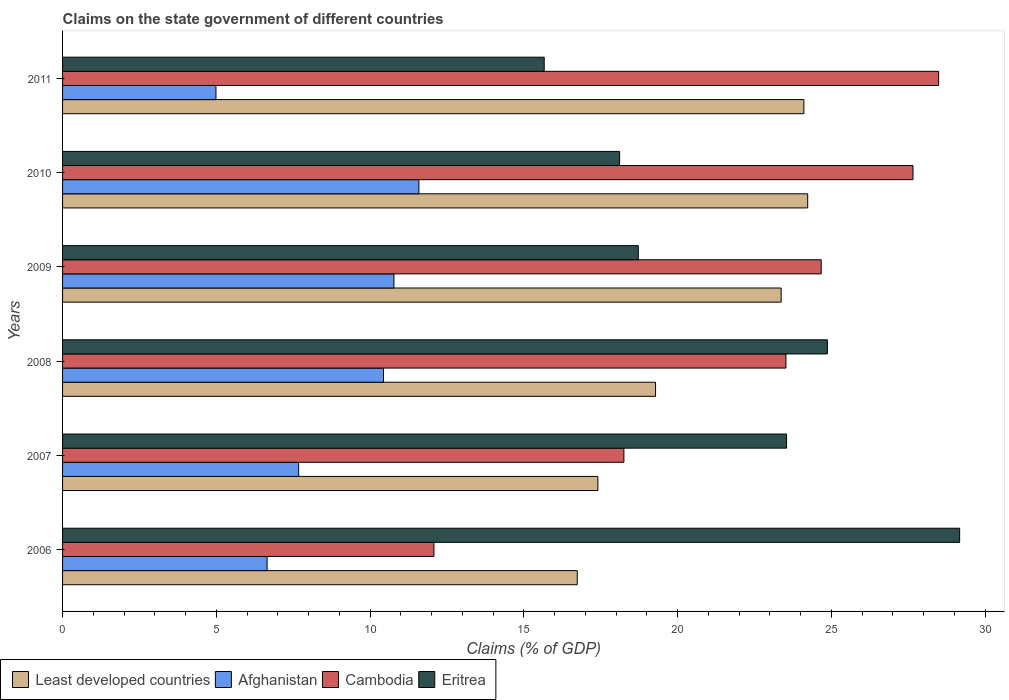How many groups of bars are there?
Provide a succinct answer. 6. Are the number of bars per tick equal to the number of legend labels?
Provide a short and direct response. Yes. What is the label of the 4th group of bars from the top?
Offer a terse response. 2008. What is the percentage of GDP claimed on the state government in Cambodia in 2010?
Offer a very short reply. 27.65. Across all years, what is the maximum percentage of GDP claimed on the state government in Eritrea?
Provide a succinct answer. 29.17. Across all years, what is the minimum percentage of GDP claimed on the state government in Least developed countries?
Keep it short and to the point. 16.74. In which year was the percentage of GDP claimed on the state government in Cambodia maximum?
Provide a succinct answer. 2011. What is the total percentage of GDP claimed on the state government in Eritrea in the graph?
Provide a succinct answer. 130.08. What is the difference between the percentage of GDP claimed on the state government in Cambodia in 2006 and that in 2011?
Make the answer very short. -16.41. What is the difference between the percentage of GDP claimed on the state government in Eritrea in 2008 and the percentage of GDP claimed on the state government in Cambodia in 2007?
Keep it short and to the point. 6.62. What is the average percentage of GDP claimed on the state government in Eritrea per year?
Offer a very short reply. 21.68. In the year 2006, what is the difference between the percentage of GDP claimed on the state government in Eritrea and percentage of GDP claimed on the state government in Least developed countries?
Your response must be concise. 12.43. In how many years, is the percentage of GDP claimed on the state government in Cambodia greater than 18 %?
Make the answer very short. 5. What is the ratio of the percentage of GDP claimed on the state government in Eritrea in 2007 to that in 2009?
Make the answer very short. 1.26. Is the percentage of GDP claimed on the state government in Afghanistan in 2007 less than that in 2008?
Make the answer very short. Yes. Is the difference between the percentage of GDP claimed on the state government in Eritrea in 2010 and 2011 greater than the difference between the percentage of GDP claimed on the state government in Least developed countries in 2010 and 2011?
Provide a short and direct response. Yes. What is the difference between the highest and the second highest percentage of GDP claimed on the state government in Cambodia?
Give a very brief answer. 0.83. What is the difference between the highest and the lowest percentage of GDP claimed on the state government in Least developed countries?
Your answer should be compact. 7.49. What does the 1st bar from the top in 2007 represents?
Your answer should be very brief. Eritrea. What does the 4th bar from the bottom in 2008 represents?
Offer a terse response. Eritrea. How many years are there in the graph?
Provide a succinct answer. 6. What is the difference between two consecutive major ticks on the X-axis?
Provide a short and direct response. 5. Does the graph contain any zero values?
Ensure brevity in your answer.  No. Where does the legend appear in the graph?
Keep it short and to the point. Bottom left. How many legend labels are there?
Provide a short and direct response. 4. How are the legend labels stacked?
Give a very brief answer. Horizontal. What is the title of the graph?
Give a very brief answer. Claims on the state government of different countries. Does "Syrian Arab Republic" appear as one of the legend labels in the graph?
Provide a succinct answer. No. What is the label or title of the X-axis?
Provide a short and direct response. Claims (% of GDP). What is the label or title of the Y-axis?
Your answer should be very brief. Years. What is the Claims (% of GDP) in Least developed countries in 2006?
Offer a very short reply. 16.74. What is the Claims (% of GDP) in Afghanistan in 2006?
Give a very brief answer. 6.65. What is the Claims (% of GDP) in Cambodia in 2006?
Your response must be concise. 12.08. What is the Claims (% of GDP) of Eritrea in 2006?
Keep it short and to the point. 29.17. What is the Claims (% of GDP) in Least developed countries in 2007?
Provide a succinct answer. 17.41. What is the Claims (% of GDP) in Afghanistan in 2007?
Ensure brevity in your answer.  7.68. What is the Claims (% of GDP) in Cambodia in 2007?
Ensure brevity in your answer.  18.25. What is the Claims (% of GDP) in Eritrea in 2007?
Provide a succinct answer. 23.54. What is the Claims (% of GDP) of Least developed countries in 2008?
Offer a terse response. 19.28. What is the Claims (% of GDP) of Afghanistan in 2008?
Offer a terse response. 10.44. What is the Claims (% of GDP) in Cambodia in 2008?
Ensure brevity in your answer.  23.52. What is the Claims (% of GDP) of Eritrea in 2008?
Your response must be concise. 24.87. What is the Claims (% of GDP) in Least developed countries in 2009?
Make the answer very short. 23.37. What is the Claims (% of GDP) in Afghanistan in 2009?
Your answer should be very brief. 10.78. What is the Claims (% of GDP) in Cambodia in 2009?
Provide a short and direct response. 24.67. What is the Claims (% of GDP) in Eritrea in 2009?
Offer a terse response. 18.72. What is the Claims (% of GDP) of Least developed countries in 2010?
Make the answer very short. 24.23. What is the Claims (% of GDP) in Afghanistan in 2010?
Offer a terse response. 11.59. What is the Claims (% of GDP) in Cambodia in 2010?
Your answer should be compact. 27.65. What is the Claims (% of GDP) in Eritrea in 2010?
Offer a very short reply. 18.11. What is the Claims (% of GDP) of Least developed countries in 2011?
Your response must be concise. 24.11. What is the Claims (% of GDP) of Afghanistan in 2011?
Give a very brief answer. 4.99. What is the Claims (% of GDP) of Cambodia in 2011?
Offer a very short reply. 28.49. What is the Claims (% of GDP) of Eritrea in 2011?
Make the answer very short. 15.66. Across all years, what is the maximum Claims (% of GDP) of Least developed countries?
Keep it short and to the point. 24.23. Across all years, what is the maximum Claims (% of GDP) in Afghanistan?
Your answer should be very brief. 11.59. Across all years, what is the maximum Claims (% of GDP) of Cambodia?
Ensure brevity in your answer.  28.49. Across all years, what is the maximum Claims (% of GDP) in Eritrea?
Your response must be concise. 29.17. Across all years, what is the minimum Claims (% of GDP) of Least developed countries?
Give a very brief answer. 16.74. Across all years, what is the minimum Claims (% of GDP) of Afghanistan?
Offer a very short reply. 4.99. Across all years, what is the minimum Claims (% of GDP) of Cambodia?
Your response must be concise. 12.08. Across all years, what is the minimum Claims (% of GDP) in Eritrea?
Provide a short and direct response. 15.66. What is the total Claims (% of GDP) in Least developed countries in the graph?
Provide a short and direct response. 125.12. What is the total Claims (% of GDP) in Afghanistan in the graph?
Keep it short and to the point. 52.11. What is the total Claims (% of GDP) in Cambodia in the graph?
Provide a short and direct response. 134.66. What is the total Claims (% of GDP) of Eritrea in the graph?
Your response must be concise. 130.08. What is the difference between the Claims (% of GDP) in Least developed countries in 2006 and that in 2007?
Offer a very short reply. -0.67. What is the difference between the Claims (% of GDP) of Afghanistan in 2006 and that in 2007?
Your answer should be very brief. -1.03. What is the difference between the Claims (% of GDP) of Cambodia in 2006 and that in 2007?
Your answer should be very brief. -6.18. What is the difference between the Claims (% of GDP) of Eritrea in 2006 and that in 2007?
Offer a very short reply. 5.63. What is the difference between the Claims (% of GDP) of Least developed countries in 2006 and that in 2008?
Keep it short and to the point. -2.55. What is the difference between the Claims (% of GDP) of Afghanistan in 2006 and that in 2008?
Offer a very short reply. -3.79. What is the difference between the Claims (% of GDP) of Cambodia in 2006 and that in 2008?
Keep it short and to the point. -11.45. What is the difference between the Claims (% of GDP) of Eritrea in 2006 and that in 2008?
Ensure brevity in your answer.  4.3. What is the difference between the Claims (% of GDP) of Least developed countries in 2006 and that in 2009?
Provide a succinct answer. -6.63. What is the difference between the Claims (% of GDP) of Afghanistan in 2006 and that in 2009?
Provide a succinct answer. -4.12. What is the difference between the Claims (% of GDP) in Cambodia in 2006 and that in 2009?
Offer a terse response. -12.59. What is the difference between the Claims (% of GDP) in Eritrea in 2006 and that in 2009?
Offer a terse response. 10.45. What is the difference between the Claims (% of GDP) of Least developed countries in 2006 and that in 2010?
Make the answer very short. -7.49. What is the difference between the Claims (% of GDP) in Afghanistan in 2006 and that in 2010?
Give a very brief answer. -4.94. What is the difference between the Claims (% of GDP) of Cambodia in 2006 and that in 2010?
Your answer should be very brief. -15.58. What is the difference between the Claims (% of GDP) in Eritrea in 2006 and that in 2010?
Give a very brief answer. 11.06. What is the difference between the Claims (% of GDP) of Least developed countries in 2006 and that in 2011?
Provide a succinct answer. -7.37. What is the difference between the Claims (% of GDP) of Afghanistan in 2006 and that in 2011?
Make the answer very short. 1.66. What is the difference between the Claims (% of GDP) in Cambodia in 2006 and that in 2011?
Give a very brief answer. -16.41. What is the difference between the Claims (% of GDP) in Eritrea in 2006 and that in 2011?
Give a very brief answer. 13.51. What is the difference between the Claims (% of GDP) of Least developed countries in 2007 and that in 2008?
Provide a succinct answer. -1.88. What is the difference between the Claims (% of GDP) of Afghanistan in 2007 and that in 2008?
Keep it short and to the point. -2.76. What is the difference between the Claims (% of GDP) of Cambodia in 2007 and that in 2008?
Offer a terse response. -5.27. What is the difference between the Claims (% of GDP) in Eritrea in 2007 and that in 2008?
Your answer should be very brief. -1.33. What is the difference between the Claims (% of GDP) in Least developed countries in 2007 and that in 2009?
Give a very brief answer. -5.96. What is the difference between the Claims (% of GDP) in Afghanistan in 2007 and that in 2009?
Give a very brief answer. -3.1. What is the difference between the Claims (% of GDP) in Cambodia in 2007 and that in 2009?
Your response must be concise. -6.42. What is the difference between the Claims (% of GDP) in Eritrea in 2007 and that in 2009?
Your answer should be compact. 4.82. What is the difference between the Claims (% of GDP) of Least developed countries in 2007 and that in 2010?
Ensure brevity in your answer.  -6.82. What is the difference between the Claims (% of GDP) in Afghanistan in 2007 and that in 2010?
Provide a short and direct response. -3.91. What is the difference between the Claims (% of GDP) in Cambodia in 2007 and that in 2010?
Your answer should be very brief. -9.4. What is the difference between the Claims (% of GDP) in Eritrea in 2007 and that in 2010?
Provide a succinct answer. 5.43. What is the difference between the Claims (% of GDP) in Least developed countries in 2007 and that in 2011?
Offer a very short reply. -6.7. What is the difference between the Claims (% of GDP) in Afghanistan in 2007 and that in 2011?
Ensure brevity in your answer.  2.69. What is the difference between the Claims (% of GDP) of Cambodia in 2007 and that in 2011?
Ensure brevity in your answer.  -10.23. What is the difference between the Claims (% of GDP) of Eritrea in 2007 and that in 2011?
Your response must be concise. 7.88. What is the difference between the Claims (% of GDP) of Least developed countries in 2008 and that in 2009?
Provide a short and direct response. -4.08. What is the difference between the Claims (% of GDP) in Afghanistan in 2008 and that in 2009?
Offer a very short reply. -0.34. What is the difference between the Claims (% of GDP) in Cambodia in 2008 and that in 2009?
Your answer should be compact. -1.15. What is the difference between the Claims (% of GDP) of Eritrea in 2008 and that in 2009?
Offer a very short reply. 6.15. What is the difference between the Claims (% of GDP) of Least developed countries in 2008 and that in 2010?
Provide a succinct answer. -4.95. What is the difference between the Claims (% of GDP) of Afghanistan in 2008 and that in 2010?
Give a very brief answer. -1.15. What is the difference between the Claims (% of GDP) of Cambodia in 2008 and that in 2010?
Ensure brevity in your answer.  -4.13. What is the difference between the Claims (% of GDP) in Eritrea in 2008 and that in 2010?
Your answer should be very brief. 6.76. What is the difference between the Claims (% of GDP) of Least developed countries in 2008 and that in 2011?
Your answer should be very brief. -4.82. What is the difference between the Claims (% of GDP) in Afghanistan in 2008 and that in 2011?
Ensure brevity in your answer.  5.45. What is the difference between the Claims (% of GDP) in Cambodia in 2008 and that in 2011?
Make the answer very short. -4.97. What is the difference between the Claims (% of GDP) of Eritrea in 2008 and that in 2011?
Make the answer very short. 9.21. What is the difference between the Claims (% of GDP) of Least developed countries in 2009 and that in 2010?
Your response must be concise. -0.86. What is the difference between the Claims (% of GDP) in Afghanistan in 2009 and that in 2010?
Offer a terse response. -0.81. What is the difference between the Claims (% of GDP) in Cambodia in 2009 and that in 2010?
Provide a succinct answer. -2.98. What is the difference between the Claims (% of GDP) of Eritrea in 2009 and that in 2010?
Provide a short and direct response. 0.61. What is the difference between the Claims (% of GDP) in Least developed countries in 2009 and that in 2011?
Provide a short and direct response. -0.74. What is the difference between the Claims (% of GDP) of Afghanistan in 2009 and that in 2011?
Make the answer very short. 5.79. What is the difference between the Claims (% of GDP) of Cambodia in 2009 and that in 2011?
Ensure brevity in your answer.  -3.82. What is the difference between the Claims (% of GDP) in Eritrea in 2009 and that in 2011?
Your response must be concise. 3.06. What is the difference between the Claims (% of GDP) in Least developed countries in 2010 and that in 2011?
Keep it short and to the point. 0.12. What is the difference between the Claims (% of GDP) of Afghanistan in 2010 and that in 2011?
Provide a short and direct response. 6.6. What is the difference between the Claims (% of GDP) of Cambodia in 2010 and that in 2011?
Give a very brief answer. -0.83. What is the difference between the Claims (% of GDP) in Eritrea in 2010 and that in 2011?
Keep it short and to the point. 2.45. What is the difference between the Claims (% of GDP) in Least developed countries in 2006 and the Claims (% of GDP) in Afghanistan in 2007?
Keep it short and to the point. 9.06. What is the difference between the Claims (% of GDP) in Least developed countries in 2006 and the Claims (% of GDP) in Cambodia in 2007?
Your response must be concise. -1.52. What is the difference between the Claims (% of GDP) in Least developed countries in 2006 and the Claims (% of GDP) in Eritrea in 2007?
Keep it short and to the point. -6.81. What is the difference between the Claims (% of GDP) of Afghanistan in 2006 and the Claims (% of GDP) of Cambodia in 2007?
Your answer should be very brief. -11.6. What is the difference between the Claims (% of GDP) of Afghanistan in 2006 and the Claims (% of GDP) of Eritrea in 2007?
Make the answer very short. -16.89. What is the difference between the Claims (% of GDP) in Cambodia in 2006 and the Claims (% of GDP) in Eritrea in 2007?
Offer a terse response. -11.47. What is the difference between the Claims (% of GDP) of Least developed countries in 2006 and the Claims (% of GDP) of Afghanistan in 2008?
Provide a short and direct response. 6.3. What is the difference between the Claims (% of GDP) in Least developed countries in 2006 and the Claims (% of GDP) in Cambodia in 2008?
Ensure brevity in your answer.  -6.79. What is the difference between the Claims (% of GDP) of Least developed countries in 2006 and the Claims (% of GDP) of Eritrea in 2008?
Ensure brevity in your answer.  -8.13. What is the difference between the Claims (% of GDP) of Afghanistan in 2006 and the Claims (% of GDP) of Cambodia in 2008?
Ensure brevity in your answer.  -16.87. What is the difference between the Claims (% of GDP) in Afghanistan in 2006 and the Claims (% of GDP) in Eritrea in 2008?
Offer a terse response. -18.22. What is the difference between the Claims (% of GDP) of Cambodia in 2006 and the Claims (% of GDP) of Eritrea in 2008?
Provide a short and direct response. -12.79. What is the difference between the Claims (% of GDP) in Least developed countries in 2006 and the Claims (% of GDP) in Afghanistan in 2009?
Your response must be concise. 5.96. What is the difference between the Claims (% of GDP) in Least developed countries in 2006 and the Claims (% of GDP) in Cambodia in 2009?
Give a very brief answer. -7.93. What is the difference between the Claims (% of GDP) of Least developed countries in 2006 and the Claims (% of GDP) of Eritrea in 2009?
Your answer should be compact. -1.98. What is the difference between the Claims (% of GDP) in Afghanistan in 2006 and the Claims (% of GDP) in Cambodia in 2009?
Ensure brevity in your answer.  -18.02. What is the difference between the Claims (% of GDP) in Afghanistan in 2006 and the Claims (% of GDP) in Eritrea in 2009?
Ensure brevity in your answer.  -12.07. What is the difference between the Claims (% of GDP) in Cambodia in 2006 and the Claims (% of GDP) in Eritrea in 2009?
Give a very brief answer. -6.64. What is the difference between the Claims (% of GDP) of Least developed countries in 2006 and the Claims (% of GDP) of Afghanistan in 2010?
Provide a succinct answer. 5.15. What is the difference between the Claims (% of GDP) of Least developed countries in 2006 and the Claims (% of GDP) of Cambodia in 2010?
Your response must be concise. -10.92. What is the difference between the Claims (% of GDP) of Least developed countries in 2006 and the Claims (% of GDP) of Eritrea in 2010?
Provide a succinct answer. -1.38. What is the difference between the Claims (% of GDP) of Afghanistan in 2006 and the Claims (% of GDP) of Cambodia in 2010?
Your answer should be compact. -21. What is the difference between the Claims (% of GDP) in Afghanistan in 2006 and the Claims (% of GDP) in Eritrea in 2010?
Ensure brevity in your answer.  -11.46. What is the difference between the Claims (% of GDP) of Cambodia in 2006 and the Claims (% of GDP) of Eritrea in 2010?
Your answer should be very brief. -6.04. What is the difference between the Claims (% of GDP) of Least developed countries in 2006 and the Claims (% of GDP) of Afghanistan in 2011?
Make the answer very short. 11.75. What is the difference between the Claims (% of GDP) in Least developed countries in 2006 and the Claims (% of GDP) in Cambodia in 2011?
Your response must be concise. -11.75. What is the difference between the Claims (% of GDP) in Least developed countries in 2006 and the Claims (% of GDP) in Eritrea in 2011?
Ensure brevity in your answer.  1.08. What is the difference between the Claims (% of GDP) in Afghanistan in 2006 and the Claims (% of GDP) in Cambodia in 2011?
Offer a very short reply. -21.84. What is the difference between the Claims (% of GDP) of Afghanistan in 2006 and the Claims (% of GDP) of Eritrea in 2011?
Offer a terse response. -9.01. What is the difference between the Claims (% of GDP) in Cambodia in 2006 and the Claims (% of GDP) in Eritrea in 2011?
Give a very brief answer. -3.58. What is the difference between the Claims (% of GDP) of Least developed countries in 2007 and the Claims (% of GDP) of Afghanistan in 2008?
Offer a very short reply. 6.97. What is the difference between the Claims (% of GDP) of Least developed countries in 2007 and the Claims (% of GDP) of Cambodia in 2008?
Your response must be concise. -6.12. What is the difference between the Claims (% of GDP) in Least developed countries in 2007 and the Claims (% of GDP) in Eritrea in 2008?
Ensure brevity in your answer.  -7.46. What is the difference between the Claims (% of GDP) of Afghanistan in 2007 and the Claims (% of GDP) of Cambodia in 2008?
Provide a short and direct response. -15.84. What is the difference between the Claims (% of GDP) in Afghanistan in 2007 and the Claims (% of GDP) in Eritrea in 2008?
Keep it short and to the point. -17.19. What is the difference between the Claims (% of GDP) of Cambodia in 2007 and the Claims (% of GDP) of Eritrea in 2008?
Offer a terse response. -6.62. What is the difference between the Claims (% of GDP) in Least developed countries in 2007 and the Claims (% of GDP) in Afghanistan in 2009?
Offer a very short reply. 6.63. What is the difference between the Claims (% of GDP) of Least developed countries in 2007 and the Claims (% of GDP) of Cambodia in 2009?
Offer a terse response. -7.26. What is the difference between the Claims (% of GDP) of Least developed countries in 2007 and the Claims (% of GDP) of Eritrea in 2009?
Make the answer very short. -1.31. What is the difference between the Claims (% of GDP) of Afghanistan in 2007 and the Claims (% of GDP) of Cambodia in 2009?
Your response must be concise. -16.99. What is the difference between the Claims (% of GDP) in Afghanistan in 2007 and the Claims (% of GDP) in Eritrea in 2009?
Offer a terse response. -11.04. What is the difference between the Claims (% of GDP) in Cambodia in 2007 and the Claims (% of GDP) in Eritrea in 2009?
Your answer should be compact. -0.47. What is the difference between the Claims (% of GDP) of Least developed countries in 2007 and the Claims (% of GDP) of Afghanistan in 2010?
Your answer should be compact. 5.82. What is the difference between the Claims (% of GDP) in Least developed countries in 2007 and the Claims (% of GDP) in Cambodia in 2010?
Your answer should be very brief. -10.25. What is the difference between the Claims (% of GDP) in Least developed countries in 2007 and the Claims (% of GDP) in Eritrea in 2010?
Your response must be concise. -0.71. What is the difference between the Claims (% of GDP) in Afghanistan in 2007 and the Claims (% of GDP) in Cambodia in 2010?
Offer a very short reply. -19.98. What is the difference between the Claims (% of GDP) in Afghanistan in 2007 and the Claims (% of GDP) in Eritrea in 2010?
Your answer should be very brief. -10.44. What is the difference between the Claims (% of GDP) in Cambodia in 2007 and the Claims (% of GDP) in Eritrea in 2010?
Give a very brief answer. 0.14. What is the difference between the Claims (% of GDP) of Least developed countries in 2007 and the Claims (% of GDP) of Afghanistan in 2011?
Provide a succinct answer. 12.42. What is the difference between the Claims (% of GDP) of Least developed countries in 2007 and the Claims (% of GDP) of Cambodia in 2011?
Make the answer very short. -11.08. What is the difference between the Claims (% of GDP) in Least developed countries in 2007 and the Claims (% of GDP) in Eritrea in 2011?
Make the answer very short. 1.75. What is the difference between the Claims (% of GDP) in Afghanistan in 2007 and the Claims (% of GDP) in Cambodia in 2011?
Offer a terse response. -20.81. What is the difference between the Claims (% of GDP) in Afghanistan in 2007 and the Claims (% of GDP) in Eritrea in 2011?
Give a very brief answer. -7.98. What is the difference between the Claims (% of GDP) in Cambodia in 2007 and the Claims (% of GDP) in Eritrea in 2011?
Keep it short and to the point. 2.59. What is the difference between the Claims (% of GDP) in Least developed countries in 2008 and the Claims (% of GDP) in Afghanistan in 2009?
Offer a very short reply. 8.51. What is the difference between the Claims (% of GDP) of Least developed countries in 2008 and the Claims (% of GDP) of Cambodia in 2009?
Your answer should be very brief. -5.39. What is the difference between the Claims (% of GDP) of Least developed countries in 2008 and the Claims (% of GDP) of Eritrea in 2009?
Offer a very short reply. 0.56. What is the difference between the Claims (% of GDP) in Afghanistan in 2008 and the Claims (% of GDP) in Cambodia in 2009?
Your answer should be very brief. -14.23. What is the difference between the Claims (% of GDP) in Afghanistan in 2008 and the Claims (% of GDP) in Eritrea in 2009?
Your response must be concise. -8.29. What is the difference between the Claims (% of GDP) of Cambodia in 2008 and the Claims (% of GDP) of Eritrea in 2009?
Keep it short and to the point. 4.8. What is the difference between the Claims (% of GDP) in Least developed countries in 2008 and the Claims (% of GDP) in Afghanistan in 2010?
Provide a succinct answer. 7.7. What is the difference between the Claims (% of GDP) in Least developed countries in 2008 and the Claims (% of GDP) in Cambodia in 2010?
Your response must be concise. -8.37. What is the difference between the Claims (% of GDP) in Least developed countries in 2008 and the Claims (% of GDP) in Eritrea in 2010?
Provide a short and direct response. 1.17. What is the difference between the Claims (% of GDP) of Afghanistan in 2008 and the Claims (% of GDP) of Cambodia in 2010?
Make the answer very short. -17.22. What is the difference between the Claims (% of GDP) of Afghanistan in 2008 and the Claims (% of GDP) of Eritrea in 2010?
Your answer should be compact. -7.68. What is the difference between the Claims (% of GDP) in Cambodia in 2008 and the Claims (% of GDP) in Eritrea in 2010?
Your response must be concise. 5.41. What is the difference between the Claims (% of GDP) of Least developed countries in 2008 and the Claims (% of GDP) of Afghanistan in 2011?
Give a very brief answer. 14.29. What is the difference between the Claims (% of GDP) in Least developed countries in 2008 and the Claims (% of GDP) in Cambodia in 2011?
Offer a terse response. -9.21. What is the difference between the Claims (% of GDP) in Least developed countries in 2008 and the Claims (% of GDP) in Eritrea in 2011?
Offer a very short reply. 3.62. What is the difference between the Claims (% of GDP) of Afghanistan in 2008 and the Claims (% of GDP) of Cambodia in 2011?
Provide a succinct answer. -18.05. What is the difference between the Claims (% of GDP) of Afghanistan in 2008 and the Claims (% of GDP) of Eritrea in 2011?
Give a very brief answer. -5.22. What is the difference between the Claims (% of GDP) of Cambodia in 2008 and the Claims (% of GDP) of Eritrea in 2011?
Provide a short and direct response. 7.86. What is the difference between the Claims (% of GDP) of Least developed countries in 2009 and the Claims (% of GDP) of Afghanistan in 2010?
Your answer should be very brief. 11.78. What is the difference between the Claims (% of GDP) of Least developed countries in 2009 and the Claims (% of GDP) of Cambodia in 2010?
Your answer should be compact. -4.29. What is the difference between the Claims (% of GDP) of Least developed countries in 2009 and the Claims (% of GDP) of Eritrea in 2010?
Make the answer very short. 5.25. What is the difference between the Claims (% of GDP) in Afghanistan in 2009 and the Claims (% of GDP) in Cambodia in 2010?
Ensure brevity in your answer.  -16.88. What is the difference between the Claims (% of GDP) of Afghanistan in 2009 and the Claims (% of GDP) of Eritrea in 2010?
Give a very brief answer. -7.34. What is the difference between the Claims (% of GDP) of Cambodia in 2009 and the Claims (% of GDP) of Eritrea in 2010?
Offer a very short reply. 6.55. What is the difference between the Claims (% of GDP) of Least developed countries in 2009 and the Claims (% of GDP) of Afghanistan in 2011?
Your response must be concise. 18.38. What is the difference between the Claims (% of GDP) in Least developed countries in 2009 and the Claims (% of GDP) in Cambodia in 2011?
Your answer should be very brief. -5.12. What is the difference between the Claims (% of GDP) in Least developed countries in 2009 and the Claims (% of GDP) in Eritrea in 2011?
Provide a short and direct response. 7.7. What is the difference between the Claims (% of GDP) in Afghanistan in 2009 and the Claims (% of GDP) in Cambodia in 2011?
Provide a succinct answer. -17.71. What is the difference between the Claims (% of GDP) of Afghanistan in 2009 and the Claims (% of GDP) of Eritrea in 2011?
Keep it short and to the point. -4.89. What is the difference between the Claims (% of GDP) of Cambodia in 2009 and the Claims (% of GDP) of Eritrea in 2011?
Your answer should be very brief. 9.01. What is the difference between the Claims (% of GDP) of Least developed countries in 2010 and the Claims (% of GDP) of Afghanistan in 2011?
Your answer should be compact. 19.24. What is the difference between the Claims (% of GDP) in Least developed countries in 2010 and the Claims (% of GDP) in Cambodia in 2011?
Provide a succinct answer. -4.26. What is the difference between the Claims (% of GDP) in Least developed countries in 2010 and the Claims (% of GDP) in Eritrea in 2011?
Your answer should be compact. 8.57. What is the difference between the Claims (% of GDP) in Afghanistan in 2010 and the Claims (% of GDP) in Cambodia in 2011?
Your response must be concise. -16.9. What is the difference between the Claims (% of GDP) in Afghanistan in 2010 and the Claims (% of GDP) in Eritrea in 2011?
Make the answer very short. -4.07. What is the difference between the Claims (% of GDP) of Cambodia in 2010 and the Claims (% of GDP) of Eritrea in 2011?
Make the answer very short. 11.99. What is the average Claims (% of GDP) in Least developed countries per year?
Give a very brief answer. 20.85. What is the average Claims (% of GDP) of Afghanistan per year?
Provide a succinct answer. 8.69. What is the average Claims (% of GDP) of Cambodia per year?
Provide a short and direct response. 22.44. What is the average Claims (% of GDP) of Eritrea per year?
Make the answer very short. 21.68. In the year 2006, what is the difference between the Claims (% of GDP) of Least developed countries and Claims (% of GDP) of Afghanistan?
Offer a terse response. 10.09. In the year 2006, what is the difference between the Claims (% of GDP) in Least developed countries and Claims (% of GDP) in Cambodia?
Provide a succinct answer. 4.66. In the year 2006, what is the difference between the Claims (% of GDP) in Least developed countries and Claims (% of GDP) in Eritrea?
Offer a terse response. -12.43. In the year 2006, what is the difference between the Claims (% of GDP) in Afghanistan and Claims (% of GDP) in Cambodia?
Provide a short and direct response. -5.43. In the year 2006, what is the difference between the Claims (% of GDP) in Afghanistan and Claims (% of GDP) in Eritrea?
Keep it short and to the point. -22.52. In the year 2006, what is the difference between the Claims (% of GDP) in Cambodia and Claims (% of GDP) in Eritrea?
Your answer should be very brief. -17.09. In the year 2007, what is the difference between the Claims (% of GDP) of Least developed countries and Claims (% of GDP) of Afghanistan?
Offer a very short reply. 9.73. In the year 2007, what is the difference between the Claims (% of GDP) of Least developed countries and Claims (% of GDP) of Cambodia?
Offer a very short reply. -0.85. In the year 2007, what is the difference between the Claims (% of GDP) in Least developed countries and Claims (% of GDP) in Eritrea?
Your answer should be compact. -6.14. In the year 2007, what is the difference between the Claims (% of GDP) in Afghanistan and Claims (% of GDP) in Cambodia?
Your response must be concise. -10.58. In the year 2007, what is the difference between the Claims (% of GDP) in Afghanistan and Claims (% of GDP) in Eritrea?
Offer a terse response. -15.87. In the year 2007, what is the difference between the Claims (% of GDP) in Cambodia and Claims (% of GDP) in Eritrea?
Make the answer very short. -5.29. In the year 2008, what is the difference between the Claims (% of GDP) in Least developed countries and Claims (% of GDP) in Afghanistan?
Provide a succinct answer. 8.85. In the year 2008, what is the difference between the Claims (% of GDP) of Least developed countries and Claims (% of GDP) of Cambodia?
Make the answer very short. -4.24. In the year 2008, what is the difference between the Claims (% of GDP) in Least developed countries and Claims (% of GDP) in Eritrea?
Your answer should be very brief. -5.59. In the year 2008, what is the difference between the Claims (% of GDP) of Afghanistan and Claims (% of GDP) of Cambodia?
Your answer should be very brief. -13.09. In the year 2008, what is the difference between the Claims (% of GDP) in Afghanistan and Claims (% of GDP) in Eritrea?
Offer a very short reply. -14.43. In the year 2008, what is the difference between the Claims (% of GDP) in Cambodia and Claims (% of GDP) in Eritrea?
Ensure brevity in your answer.  -1.35. In the year 2009, what is the difference between the Claims (% of GDP) in Least developed countries and Claims (% of GDP) in Afghanistan?
Ensure brevity in your answer.  12.59. In the year 2009, what is the difference between the Claims (% of GDP) in Least developed countries and Claims (% of GDP) in Cambodia?
Offer a very short reply. -1.3. In the year 2009, what is the difference between the Claims (% of GDP) of Least developed countries and Claims (% of GDP) of Eritrea?
Ensure brevity in your answer.  4.64. In the year 2009, what is the difference between the Claims (% of GDP) of Afghanistan and Claims (% of GDP) of Cambodia?
Provide a short and direct response. -13.89. In the year 2009, what is the difference between the Claims (% of GDP) of Afghanistan and Claims (% of GDP) of Eritrea?
Ensure brevity in your answer.  -7.95. In the year 2009, what is the difference between the Claims (% of GDP) in Cambodia and Claims (% of GDP) in Eritrea?
Offer a terse response. 5.95. In the year 2010, what is the difference between the Claims (% of GDP) of Least developed countries and Claims (% of GDP) of Afghanistan?
Offer a terse response. 12.64. In the year 2010, what is the difference between the Claims (% of GDP) in Least developed countries and Claims (% of GDP) in Cambodia?
Provide a succinct answer. -3.42. In the year 2010, what is the difference between the Claims (% of GDP) in Least developed countries and Claims (% of GDP) in Eritrea?
Your answer should be compact. 6.12. In the year 2010, what is the difference between the Claims (% of GDP) of Afghanistan and Claims (% of GDP) of Cambodia?
Make the answer very short. -16.07. In the year 2010, what is the difference between the Claims (% of GDP) of Afghanistan and Claims (% of GDP) of Eritrea?
Keep it short and to the point. -6.53. In the year 2010, what is the difference between the Claims (% of GDP) in Cambodia and Claims (% of GDP) in Eritrea?
Provide a short and direct response. 9.54. In the year 2011, what is the difference between the Claims (% of GDP) in Least developed countries and Claims (% of GDP) in Afghanistan?
Make the answer very short. 19.12. In the year 2011, what is the difference between the Claims (% of GDP) in Least developed countries and Claims (% of GDP) in Cambodia?
Offer a very short reply. -4.38. In the year 2011, what is the difference between the Claims (% of GDP) of Least developed countries and Claims (% of GDP) of Eritrea?
Provide a succinct answer. 8.44. In the year 2011, what is the difference between the Claims (% of GDP) in Afghanistan and Claims (% of GDP) in Cambodia?
Ensure brevity in your answer.  -23.5. In the year 2011, what is the difference between the Claims (% of GDP) in Afghanistan and Claims (% of GDP) in Eritrea?
Keep it short and to the point. -10.67. In the year 2011, what is the difference between the Claims (% of GDP) of Cambodia and Claims (% of GDP) of Eritrea?
Give a very brief answer. 12.83. What is the ratio of the Claims (% of GDP) in Least developed countries in 2006 to that in 2007?
Provide a succinct answer. 0.96. What is the ratio of the Claims (% of GDP) in Afghanistan in 2006 to that in 2007?
Your answer should be very brief. 0.87. What is the ratio of the Claims (% of GDP) in Cambodia in 2006 to that in 2007?
Make the answer very short. 0.66. What is the ratio of the Claims (% of GDP) of Eritrea in 2006 to that in 2007?
Provide a succinct answer. 1.24. What is the ratio of the Claims (% of GDP) of Least developed countries in 2006 to that in 2008?
Provide a short and direct response. 0.87. What is the ratio of the Claims (% of GDP) of Afghanistan in 2006 to that in 2008?
Make the answer very short. 0.64. What is the ratio of the Claims (% of GDP) in Cambodia in 2006 to that in 2008?
Give a very brief answer. 0.51. What is the ratio of the Claims (% of GDP) in Eritrea in 2006 to that in 2008?
Offer a very short reply. 1.17. What is the ratio of the Claims (% of GDP) of Least developed countries in 2006 to that in 2009?
Your answer should be compact. 0.72. What is the ratio of the Claims (% of GDP) of Afghanistan in 2006 to that in 2009?
Provide a short and direct response. 0.62. What is the ratio of the Claims (% of GDP) in Cambodia in 2006 to that in 2009?
Your answer should be very brief. 0.49. What is the ratio of the Claims (% of GDP) of Eritrea in 2006 to that in 2009?
Offer a terse response. 1.56. What is the ratio of the Claims (% of GDP) of Least developed countries in 2006 to that in 2010?
Give a very brief answer. 0.69. What is the ratio of the Claims (% of GDP) in Afghanistan in 2006 to that in 2010?
Keep it short and to the point. 0.57. What is the ratio of the Claims (% of GDP) in Cambodia in 2006 to that in 2010?
Your answer should be very brief. 0.44. What is the ratio of the Claims (% of GDP) in Eritrea in 2006 to that in 2010?
Keep it short and to the point. 1.61. What is the ratio of the Claims (% of GDP) in Least developed countries in 2006 to that in 2011?
Offer a terse response. 0.69. What is the ratio of the Claims (% of GDP) of Afghanistan in 2006 to that in 2011?
Make the answer very short. 1.33. What is the ratio of the Claims (% of GDP) of Cambodia in 2006 to that in 2011?
Keep it short and to the point. 0.42. What is the ratio of the Claims (% of GDP) in Eritrea in 2006 to that in 2011?
Give a very brief answer. 1.86. What is the ratio of the Claims (% of GDP) of Least developed countries in 2007 to that in 2008?
Provide a succinct answer. 0.9. What is the ratio of the Claims (% of GDP) of Afghanistan in 2007 to that in 2008?
Provide a short and direct response. 0.74. What is the ratio of the Claims (% of GDP) in Cambodia in 2007 to that in 2008?
Give a very brief answer. 0.78. What is the ratio of the Claims (% of GDP) in Eritrea in 2007 to that in 2008?
Provide a short and direct response. 0.95. What is the ratio of the Claims (% of GDP) in Least developed countries in 2007 to that in 2009?
Your response must be concise. 0.74. What is the ratio of the Claims (% of GDP) of Afghanistan in 2007 to that in 2009?
Make the answer very short. 0.71. What is the ratio of the Claims (% of GDP) in Cambodia in 2007 to that in 2009?
Ensure brevity in your answer.  0.74. What is the ratio of the Claims (% of GDP) in Eritrea in 2007 to that in 2009?
Give a very brief answer. 1.26. What is the ratio of the Claims (% of GDP) in Least developed countries in 2007 to that in 2010?
Provide a succinct answer. 0.72. What is the ratio of the Claims (% of GDP) in Afghanistan in 2007 to that in 2010?
Give a very brief answer. 0.66. What is the ratio of the Claims (% of GDP) in Cambodia in 2007 to that in 2010?
Your response must be concise. 0.66. What is the ratio of the Claims (% of GDP) in Eritrea in 2007 to that in 2010?
Offer a terse response. 1.3. What is the ratio of the Claims (% of GDP) of Least developed countries in 2007 to that in 2011?
Ensure brevity in your answer.  0.72. What is the ratio of the Claims (% of GDP) of Afghanistan in 2007 to that in 2011?
Offer a very short reply. 1.54. What is the ratio of the Claims (% of GDP) in Cambodia in 2007 to that in 2011?
Provide a succinct answer. 0.64. What is the ratio of the Claims (% of GDP) of Eritrea in 2007 to that in 2011?
Your answer should be very brief. 1.5. What is the ratio of the Claims (% of GDP) of Least developed countries in 2008 to that in 2009?
Provide a short and direct response. 0.83. What is the ratio of the Claims (% of GDP) of Afghanistan in 2008 to that in 2009?
Provide a succinct answer. 0.97. What is the ratio of the Claims (% of GDP) in Cambodia in 2008 to that in 2009?
Keep it short and to the point. 0.95. What is the ratio of the Claims (% of GDP) in Eritrea in 2008 to that in 2009?
Offer a very short reply. 1.33. What is the ratio of the Claims (% of GDP) in Least developed countries in 2008 to that in 2010?
Make the answer very short. 0.8. What is the ratio of the Claims (% of GDP) in Afghanistan in 2008 to that in 2010?
Your answer should be compact. 0.9. What is the ratio of the Claims (% of GDP) of Cambodia in 2008 to that in 2010?
Provide a short and direct response. 0.85. What is the ratio of the Claims (% of GDP) of Eritrea in 2008 to that in 2010?
Provide a succinct answer. 1.37. What is the ratio of the Claims (% of GDP) in Least developed countries in 2008 to that in 2011?
Provide a succinct answer. 0.8. What is the ratio of the Claims (% of GDP) in Afghanistan in 2008 to that in 2011?
Offer a very short reply. 2.09. What is the ratio of the Claims (% of GDP) of Cambodia in 2008 to that in 2011?
Keep it short and to the point. 0.83. What is the ratio of the Claims (% of GDP) in Eritrea in 2008 to that in 2011?
Your response must be concise. 1.59. What is the ratio of the Claims (% of GDP) in Least developed countries in 2009 to that in 2010?
Offer a very short reply. 0.96. What is the ratio of the Claims (% of GDP) of Cambodia in 2009 to that in 2010?
Provide a short and direct response. 0.89. What is the ratio of the Claims (% of GDP) of Eritrea in 2009 to that in 2010?
Give a very brief answer. 1.03. What is the ratio of the Claims (% of GDP) of Least developed countries in 2009 to that in 2011?
Your answer should be compact. 0.97. What is the ratio of the Claims (% of GDP) in Afghanistan in 2009 to that in 2011?
Your answer should be very brief. 2.16. What is the ratio of the Claims (% of GDP) of Cambodia in 2009 to that in 2011?
Give a very brief answer. 0.87. What is the ratio of the Claims (% of GDP) in Eritrea in 2009 to that in 2011?
Give a very brief answer. 1.2. What is the ratio of the Claims (% of GDP) of Afghanistan in 2010 to that in 2011?
Make the answer very short. 2.32. What is the ratio of the Claims (% of GDP) of Cambodia in 2010 to that in 2011?
Ensure brevity in your answer.  0.97. What is the ratio of the Claims (% of GDP) of Eritrea in 2010 to that in 2011?
Provide a succinct answer. 1.16. What is the difference between the highest and the second highest Claims (% of GDP) in Least developed countries?
Offer a terse response. 0.12. What is the difference between the highest and the second highest Claims (% of GDP) in Afghanistan?
Your response must be concise. 0.81. What is the difference between the highest and the second highest Claims (% of GDP) of Cambodia?
Offer a very short reply. 0.83. What is the difference between the highest and the second highest Claims (% of GDP) of Eritrea?
Your response must be concise. 4.3. What is the difference between the highest and the lowest Claims (% of GDP) in Least developed countries?
Give a very brief answer. 7.49. What is the difference between the highest and the lowest Claims (% of GDP) of Afghanistan?
Your answer should be compact. 6.6. What is the difference between the highest and the lowest Claims (% of GDP) in Cambodia?
Provide a succinct answer. 16.41. What is the difference between the highest and the lowest Claims (% of GDP) in Eritrea?
Make the answer very short. 13.51. 